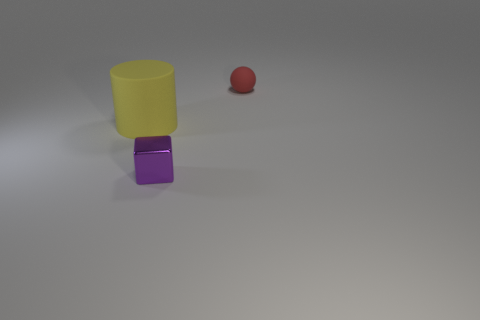Add 2 cyan cylinders. How many objects exist? 5 Subtract all cylinders. How many objects are left? 2 Add 1 small metal blocks. How many small metal blocks are left? 2 Add 2 green rubber cylinders. How many green rubber cylinders exist? 2 Subtract 1 red balls. How many objects are left? 2 Subtract all purple shiny cubes. Subtract all matte cylinders. How many objects are left? 1 